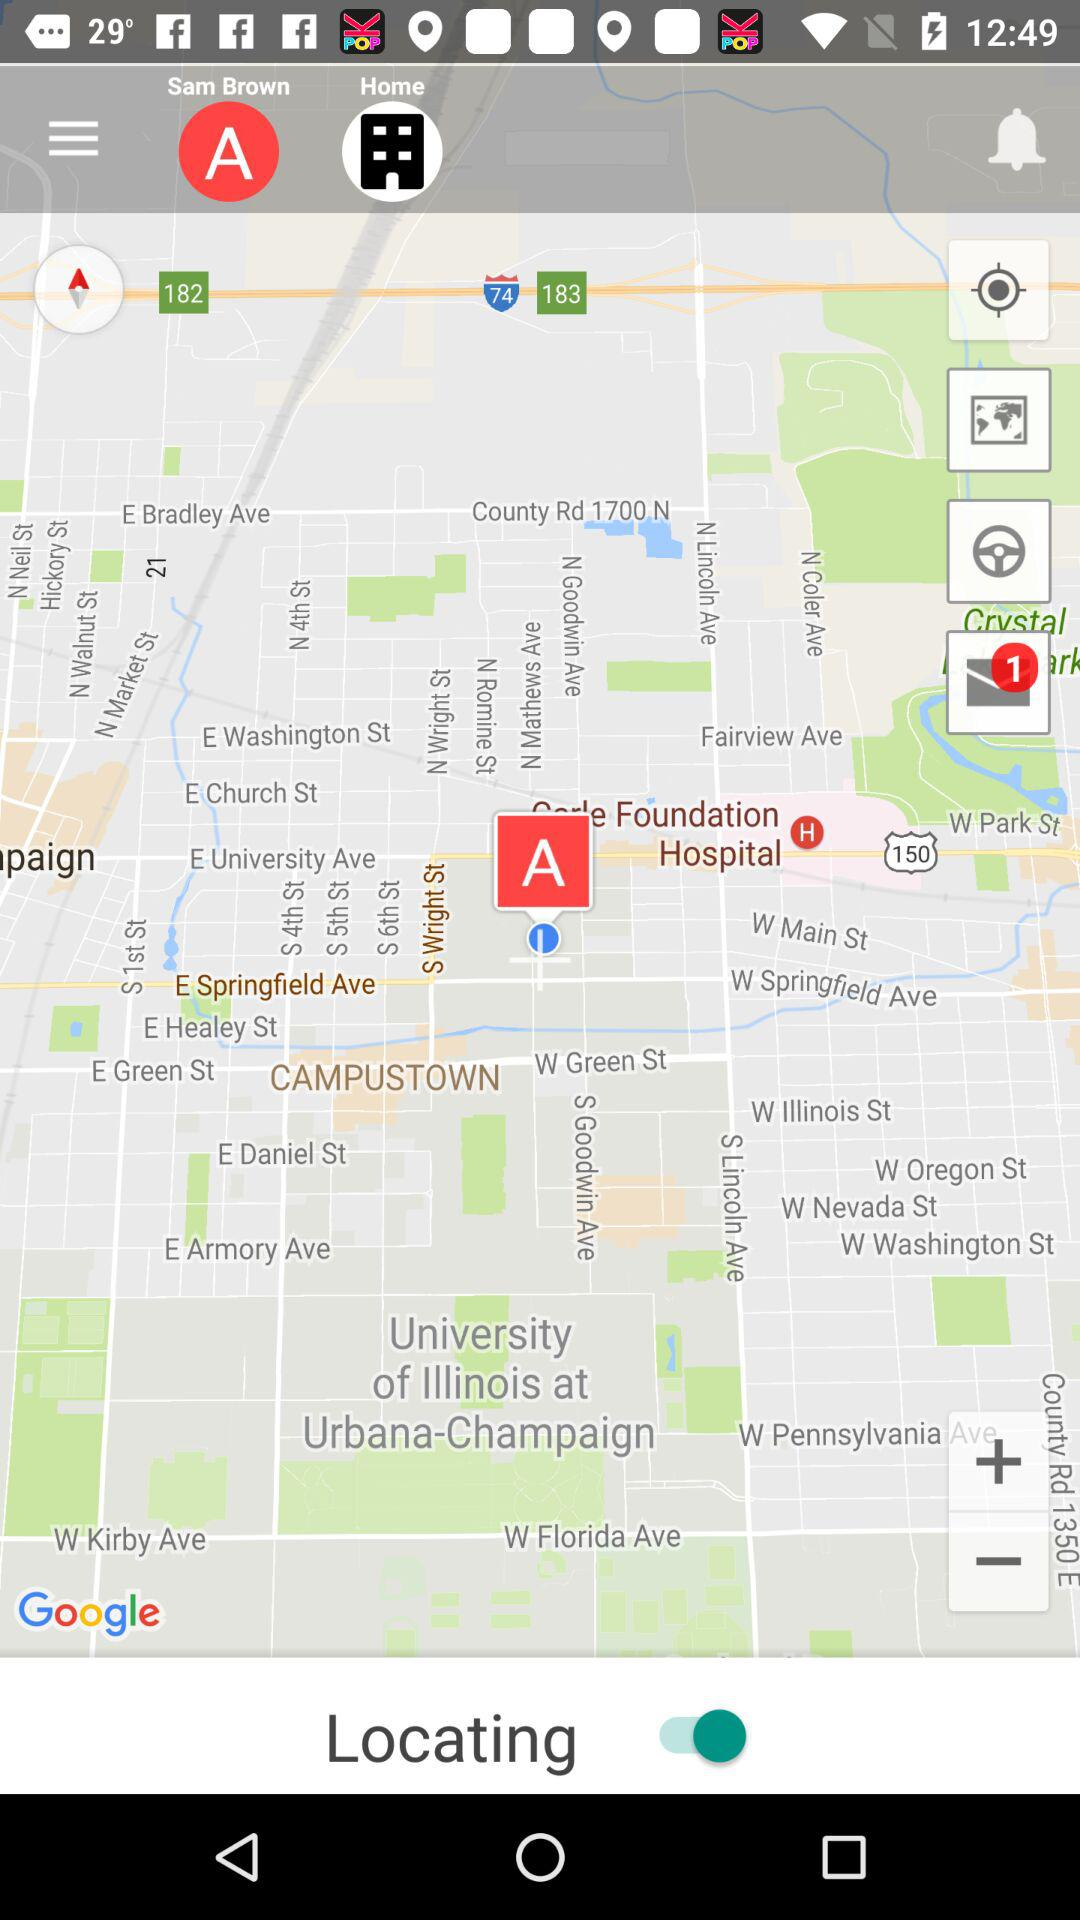What is the status of "Locating"? The status is "on". 